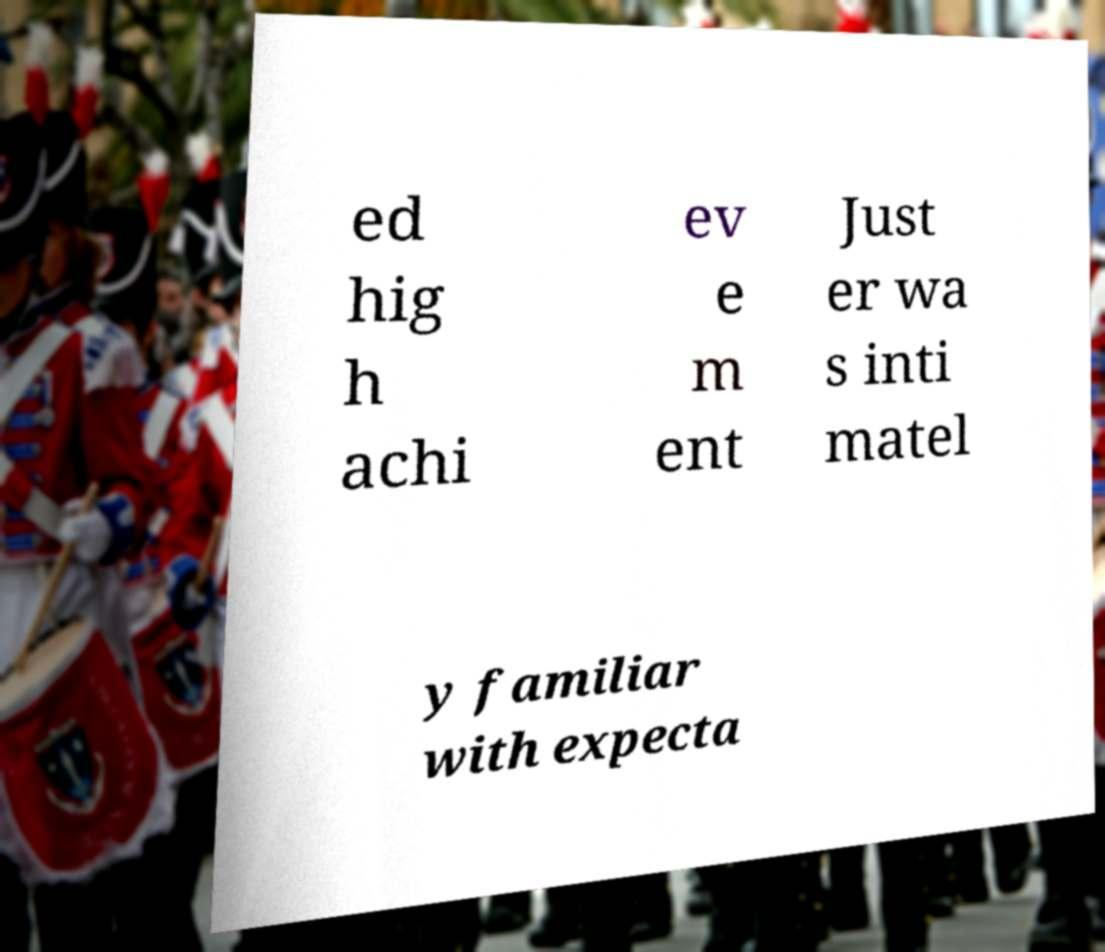For documentation purposes, I need the text within this image transcribed. Could you provide that? ed hig h achi ev e m ent Just er wa s inti matel y familiar with expecta 